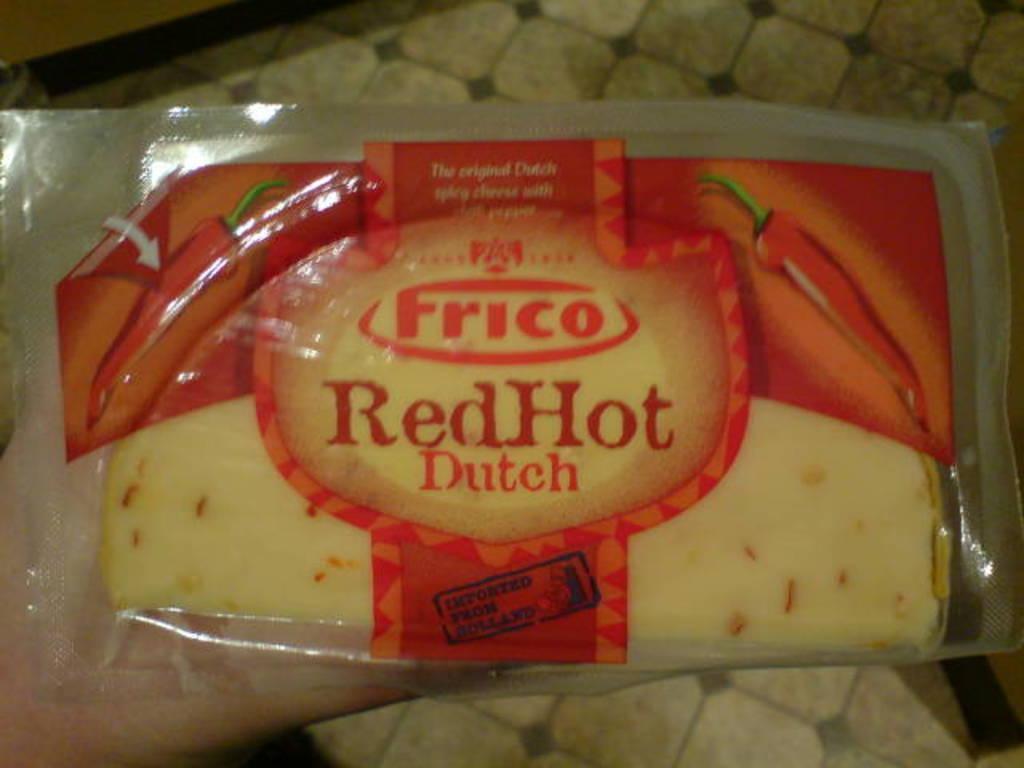Can you describe this image briefly? In this image a person is holding some food product. The food product is a packet with a red color and transparent plastic. 